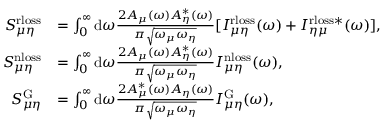<formula> <loc_0><loc_0><loc_500><loc_500>\begin{array} { r l } { S _ { \mu \eta } ^ { r l o s s } } & { = \int _ { 0 } ^ { \infty } { \mathrm d } \omega \frac { 2 A _ { \mu } ( \omega ) A _ { \eta } ^ { * } ( \omega ) } { \pi \sqrt { \omega _ { \mu } \omega _ { \eta } } } [ I _ { \mu \eta } ^ { r l o s s } ( \omega ) + I _ { \eta \mu } ^ { r l o s s * } ( \omega ) ] , } \\ { S _ { \mu \eta } ^ { n l o s s } } & { = \int _ { 0 } ^ { \infty } { \mathrm d } \omega \frac { 2 A _ { \mu } ( \omega ) A _ { \eta } ^ { * } ( \omega ) } { \pi \sqrt { \omega _ { \mu } \omega _ { \eta } } } I _ { \mu \eta } ^ { n l o s s } ( \omega ) , } \\ { S _ { \mu \eta } ^ { G } } & { = \int _ { 0 } ^ { \infty } { \mathrm d } \omega \frac { 2 A _ { \mu } ^ { * } ( \omega ) A _ { \eta } ( \omega ) } { \pi \sqrt { \omega _ { \mu } \omega _ { \eta } } } I _ { \mu \eta } ^ { G } ( \omega ) , } \end{array}</formula> 